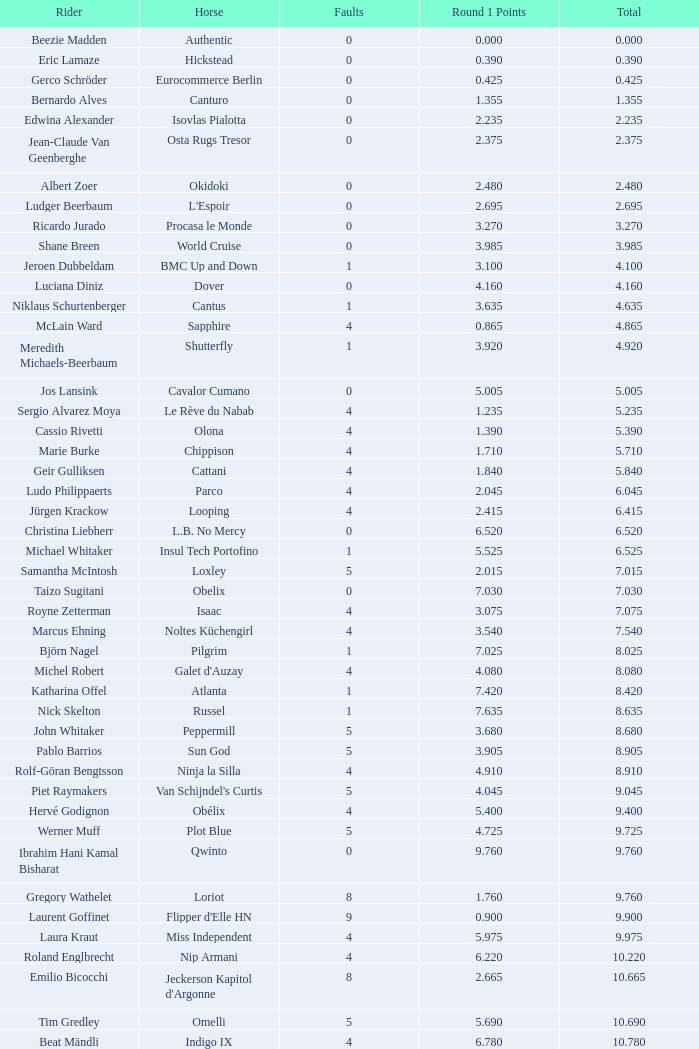Provide the greatest total for carlson's horse. 29.545. 